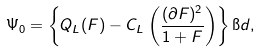<formula> <loc_0><loc_0><loc_500><loc_500>\Psi _ { 0 } = \left \{ Q _ { L } ( F ) - C _ { L } \left ( \frac { ( \partial F ) ^ { 2 } } { 1 + F } \right ) \right \} \i d ,</formula> 